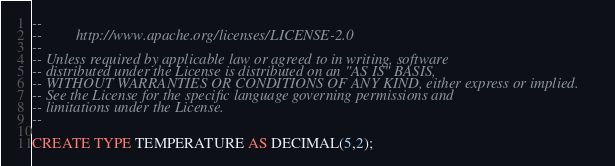<code> <loc_0><loc_0><loc_500><loc_500><_SQL_>--
--         http://www.apache.org/licenses/LICENSE-2.0
--
-- Unless required by applicable law or agreed to in writing, software
-- distributed under the License is distributed on an "AS IS" BASIS,
-- WITHOUT WARRANTIES OR CONDITIONS OF ANY KIND, either express or implied.
-- See the License for the specific language governing permissions and
-- limitations under the License.
--

CREATE TYPE TEMPERATURE AS DECIMAL(5,2);
</code> 